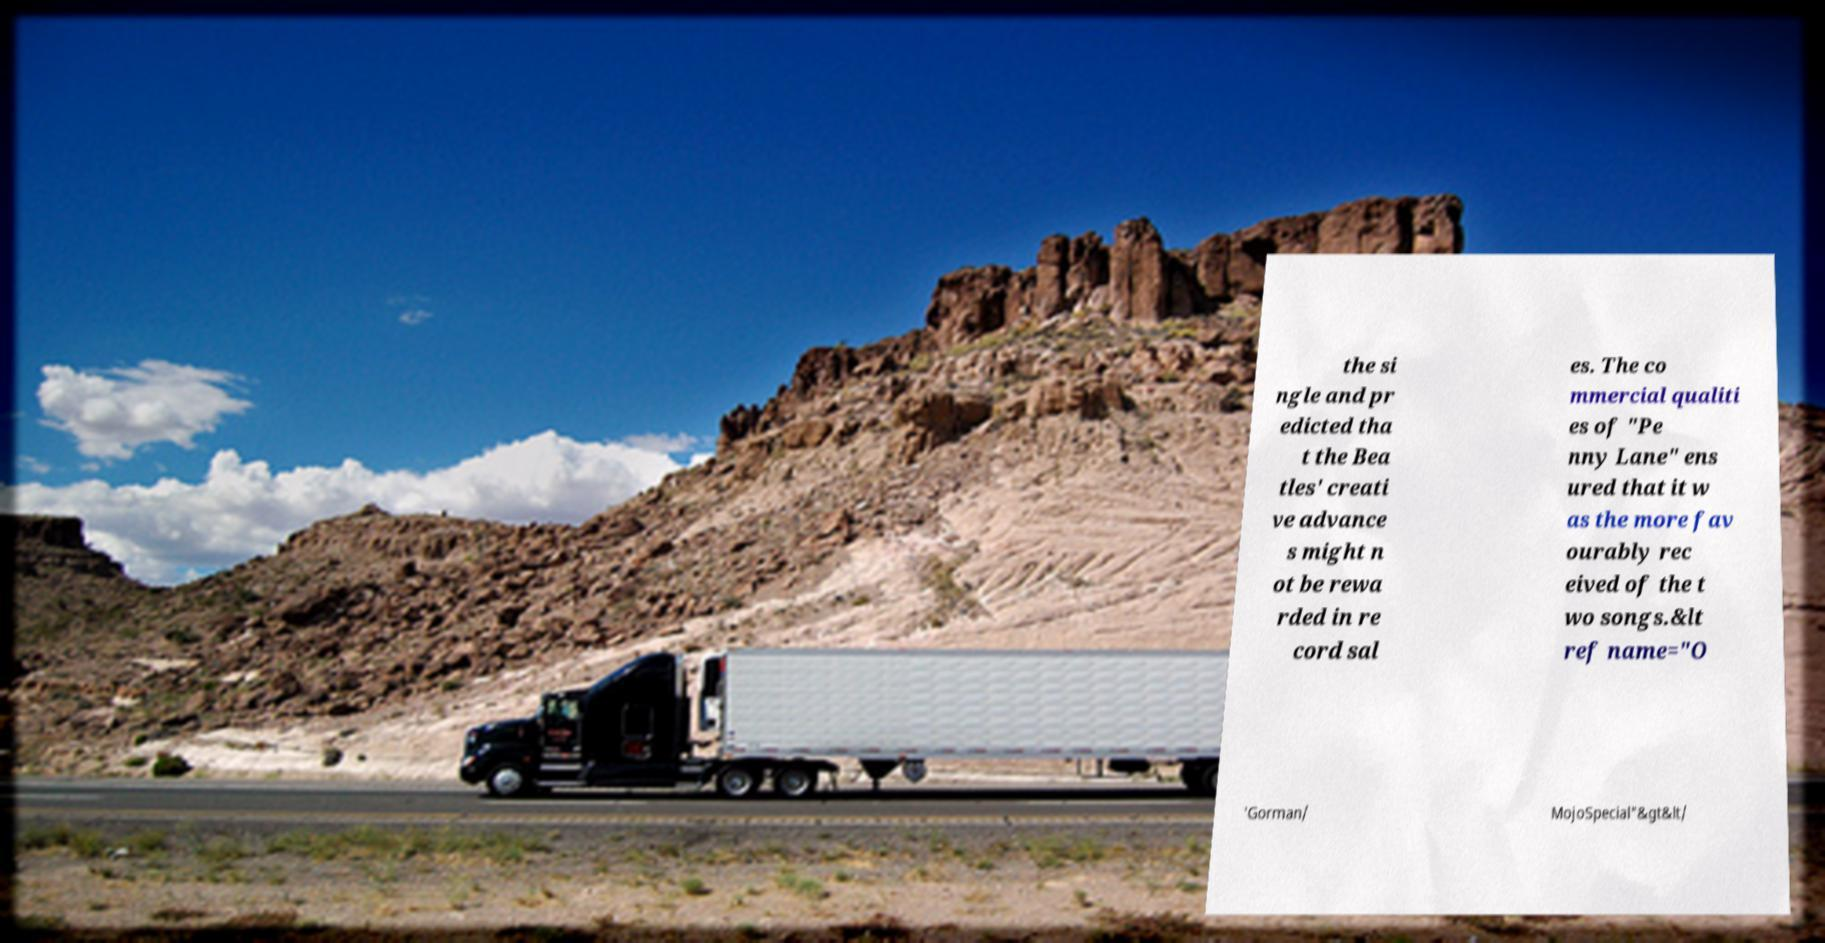Could you assist in decoding the text presented in this image and type it out clearly? the si ngle and pr edicted tha t the Bea tles' creati ve advance s might n ot be rewa rded in re cord sal es. The co mmercial qualiti es of "Pe nny Lane" ens ured that it w as the more fav ourably rec eived of the t wo songs.&lt ref name="O 'Gorman/ MojoSpecial"&gt&lt/ 